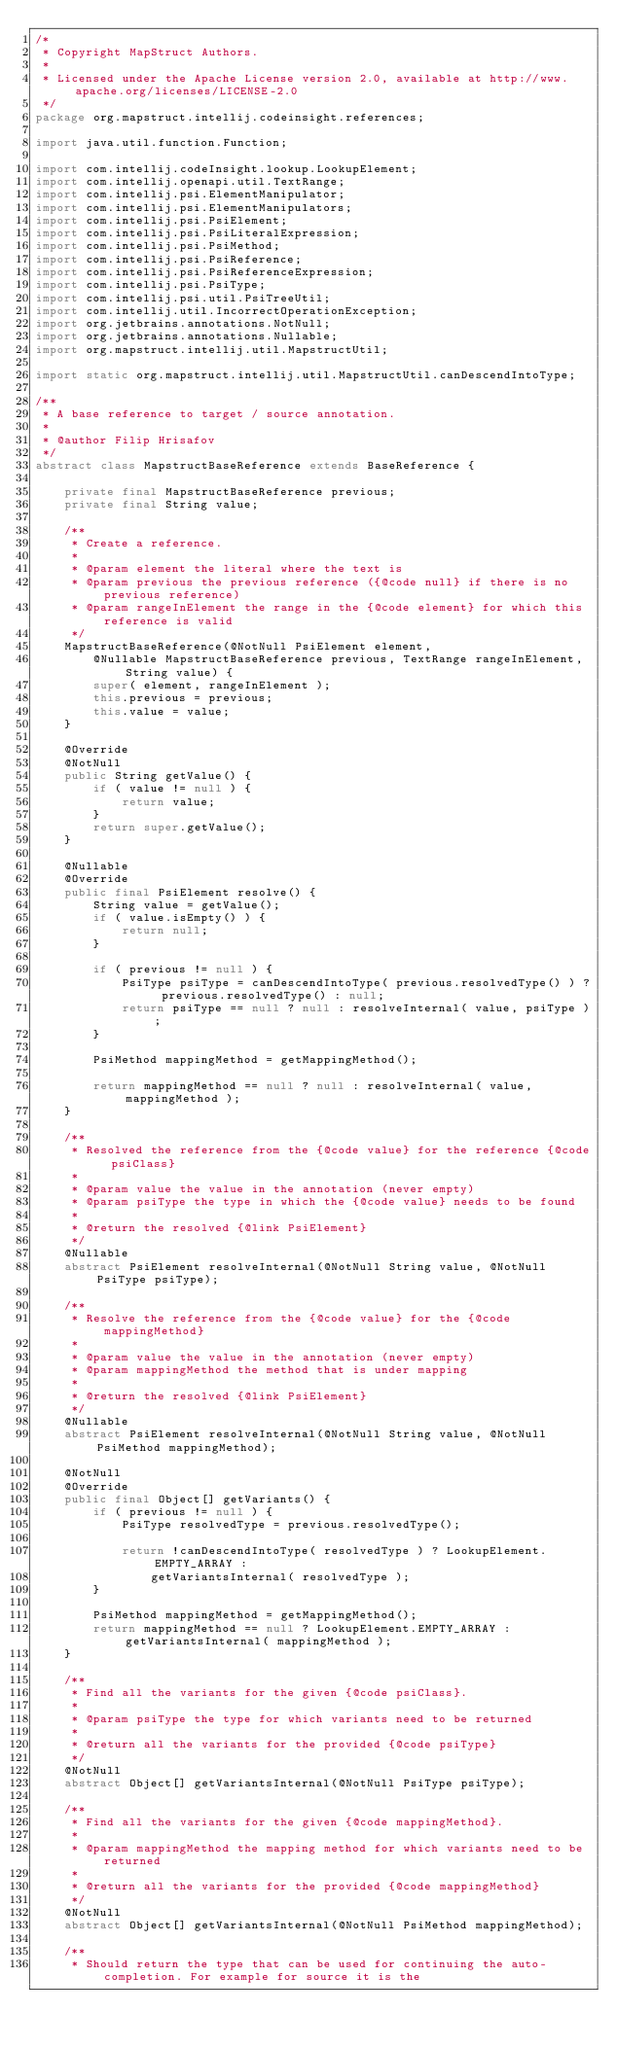Convert code to text. <code><loc_0><loc_0><loc_500><loc_500><_Java_>/*
 * Copyright MapStruct Authors.
 *
 * Licensed under the Apache License version 2.0, available at http://www.apache.org/licenses/LICENSE-2.0
 */
package org.mapstruct.intellij.codeinsight.references;

import java.util.function.Function;

import com.intellij.codeInsight.lookup.LookupElement;
import com.intellij.openapi.util.TextRange;
import com.intellij.psi.ElementManipulator;
import com.intellij.psi.ElementManipulators;
import com.intellij.psi.PsiElement;
import com.intellij.psi.PsiLiteralExpression;
import com.intellij.psi.PsiMethod;
import com.intellij.psi.PsiReference;
import com.intellij.psi.PsiReferenceExpression;
import com.intellij.psi.PsiType;
import com.intellij.psi.util.PsiTreeUtil;
import com.intellij.util.IncorrectOperationException;
import org.jetbrains.annotations.NotNull;
import org.jetbrains.annotations.Nullable;
import org.mapstruct.intellij.util.MapstructUtil;

import static org.mapstruct.intellij.util.MapstructUtil.canDescendIntoType;

/**
 * A base reference to target / source annotation.
 *
 * @author Filip Hrisafov
 */
abstract class MapstructBaseReference extends BaseReference {

    private final MapstructBaseReference previous;
    private final String value;

    /**
     * Create a reference.
     *
     * @param element the literal where the text is
     * @param previous the previous reference ({@code null} if there is no previous reference)
     * @param rangeInElement the range in the {@code element} for which this reference is valid
     */
    MapstructBaseReference(@NotNull PsiElement element,
        @Nullable MapstructBaseReference previous, TextRange rangeInElement, String value) {
        super( element, rangeInElement );
        this.previous = previous;
        this.value = value;
    }

    @Override
    @NotNull
    public String getValue() {
        if ( value != null ) {
            return value;
        }
        return super.getValue();
    }

    @Nullable
    @Override
    public final PsiElement resolve() {
        String value = getValue();
        if ( value.isEmpty() ) {
            return null;
        }

        if ( previous != null ) {
            PsiType psiType = canDescendIntoType( previous.resolvedType() ) ? previous.resolvedType() : null;
            return psiType == null ? null : resolveInternal( value, psiType );
        }

        PsiMethod mappingMethod = getMappingMethod();

        return mappingMethod == null ? null : resolveInternal( value, mappingMethod );
    }

    /**
     * Resolved the reference from the {@code value} for the reference {@code psiClass}
     *
     * @param value the value in the annotation (never empty)
     * @param psiType the type in which the {@code value} needs to be found
     *
     * @return the resolved {@link PsiElement}
     */
    @Nullable
    abstract PsiElement resolveInternal(@NotNull String value, @NotNull PsiType psiType);

    /**
     * Resolve the reference from the {@code value} for the {@code mappingMethod}
     *
     * @param value the value in the annotation (never empty)
     * @param mappingMethod the method that is under mapping
     *
     * @return the resolved {@link PsiElement}
     */
    @Nullable
    abstract PsiElement resolveInternal(@NotNull String value, @NotNull PsiMethod mappingMethod);

    @NotNull
    @Override
    public final Object[] getVariants() {
        if ( previous != null ) {
            PsiType resolvedType = previous.resolvedType();

            return !canDescendIntoType( resolvedType ) ? LookupElement.EMPTY_ARRAY :
                getVariantsInternal( resolvedType );
        }

        PsiMethod mappingMethod = getMappingMethod();
        return mappingMethod == null ? LookupElement.EMPTY_ARRAY : getVariantsInternal( mappingMethod );
    }

    /**
     * Find all the variants for the given {@code psiClass}.
     *
     * @param psiType the type for which variants need to be returned
     *
     * @return all the variants for the provided {@code psiType}
     */
    @NotNull
    abstract Object[] getVariantsInternal(@NotNull PsiType psiType);

    /**
     * Find all the variants for the given {@code mappingMethod}.
     *
     * @param mappingMethod the mapping method for which variants need to be returned
     *
     * @return all the variants for the provided {@code mappingMethod}
     */
    @NotNull
    abstract Object[] getVariantsInternal(@NotNull PsiMethod mappingMethod);

    /**
     * Should return the type that can be used for continuing the auto-completion. For example for source it is the</code> 